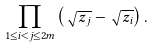<formula> <loc_0><loc_0><loc_500><loc_500>\prod _ { 1 \leq i < j \leq 2 m } \left ( \sqrt { z _ { j } } - \sqrt { z _ { i } } \right ) .</formula> 